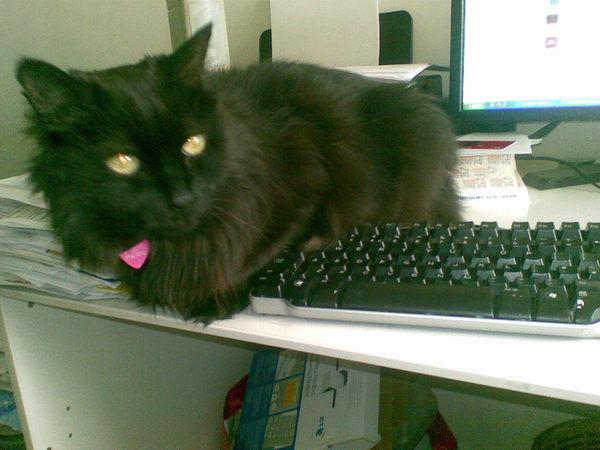Is this a skunk?
Quick response, please. No. What color is the cat?
Write a very short answer. Black. What color is the ID tag?
Answer briefly. Pink. 